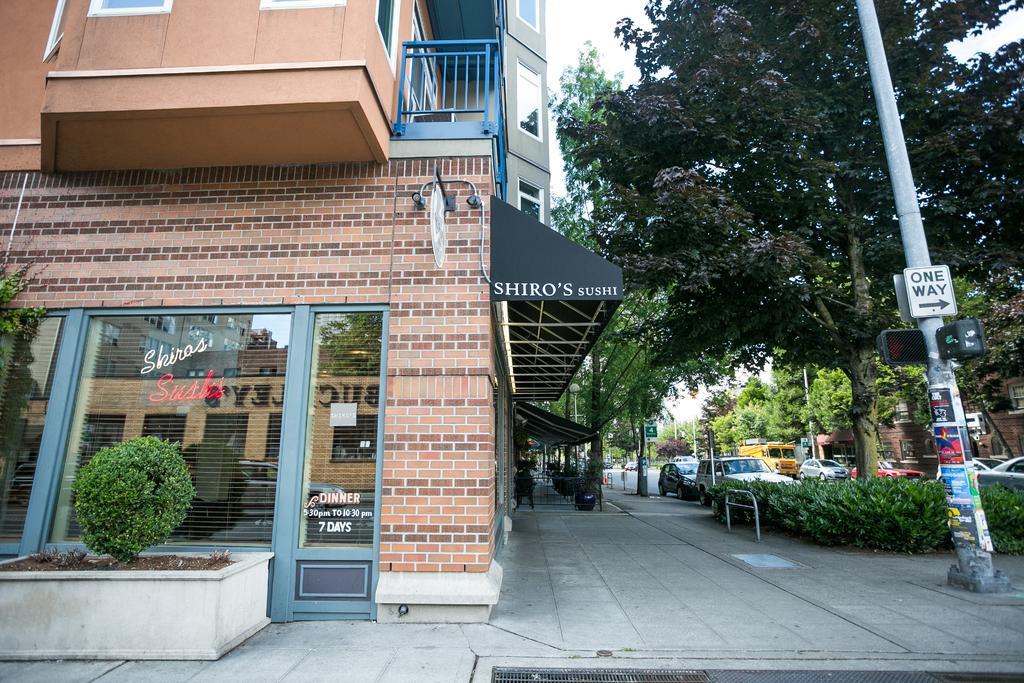Can you describe this image briefly? The image is taken on the streets of a city. On the left there are buildings, plant, door, brick wall, board and a footpath. In the center of the picture it is footpath. On the right there are plants, pole, board and trees. In the center of the background there are trees, cars, road, people and many other objects. 